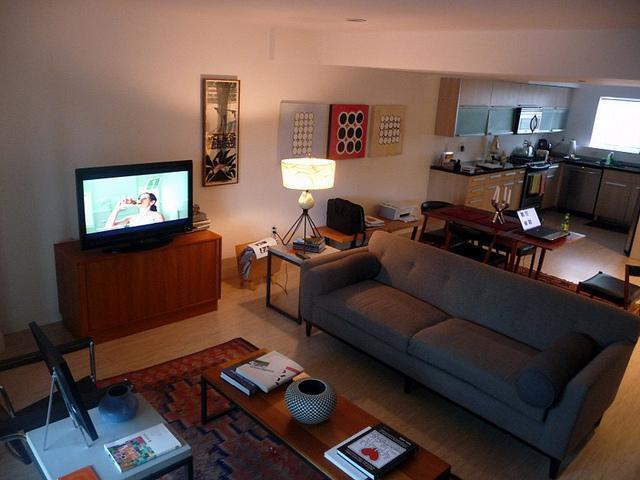How many people are in this photo?
Give a very brief answer. 0. How many books are there?
Give a very brief answer. 2. How many bikes have a helmet attached to the handlebar?
Give a very brief answer. 0. 